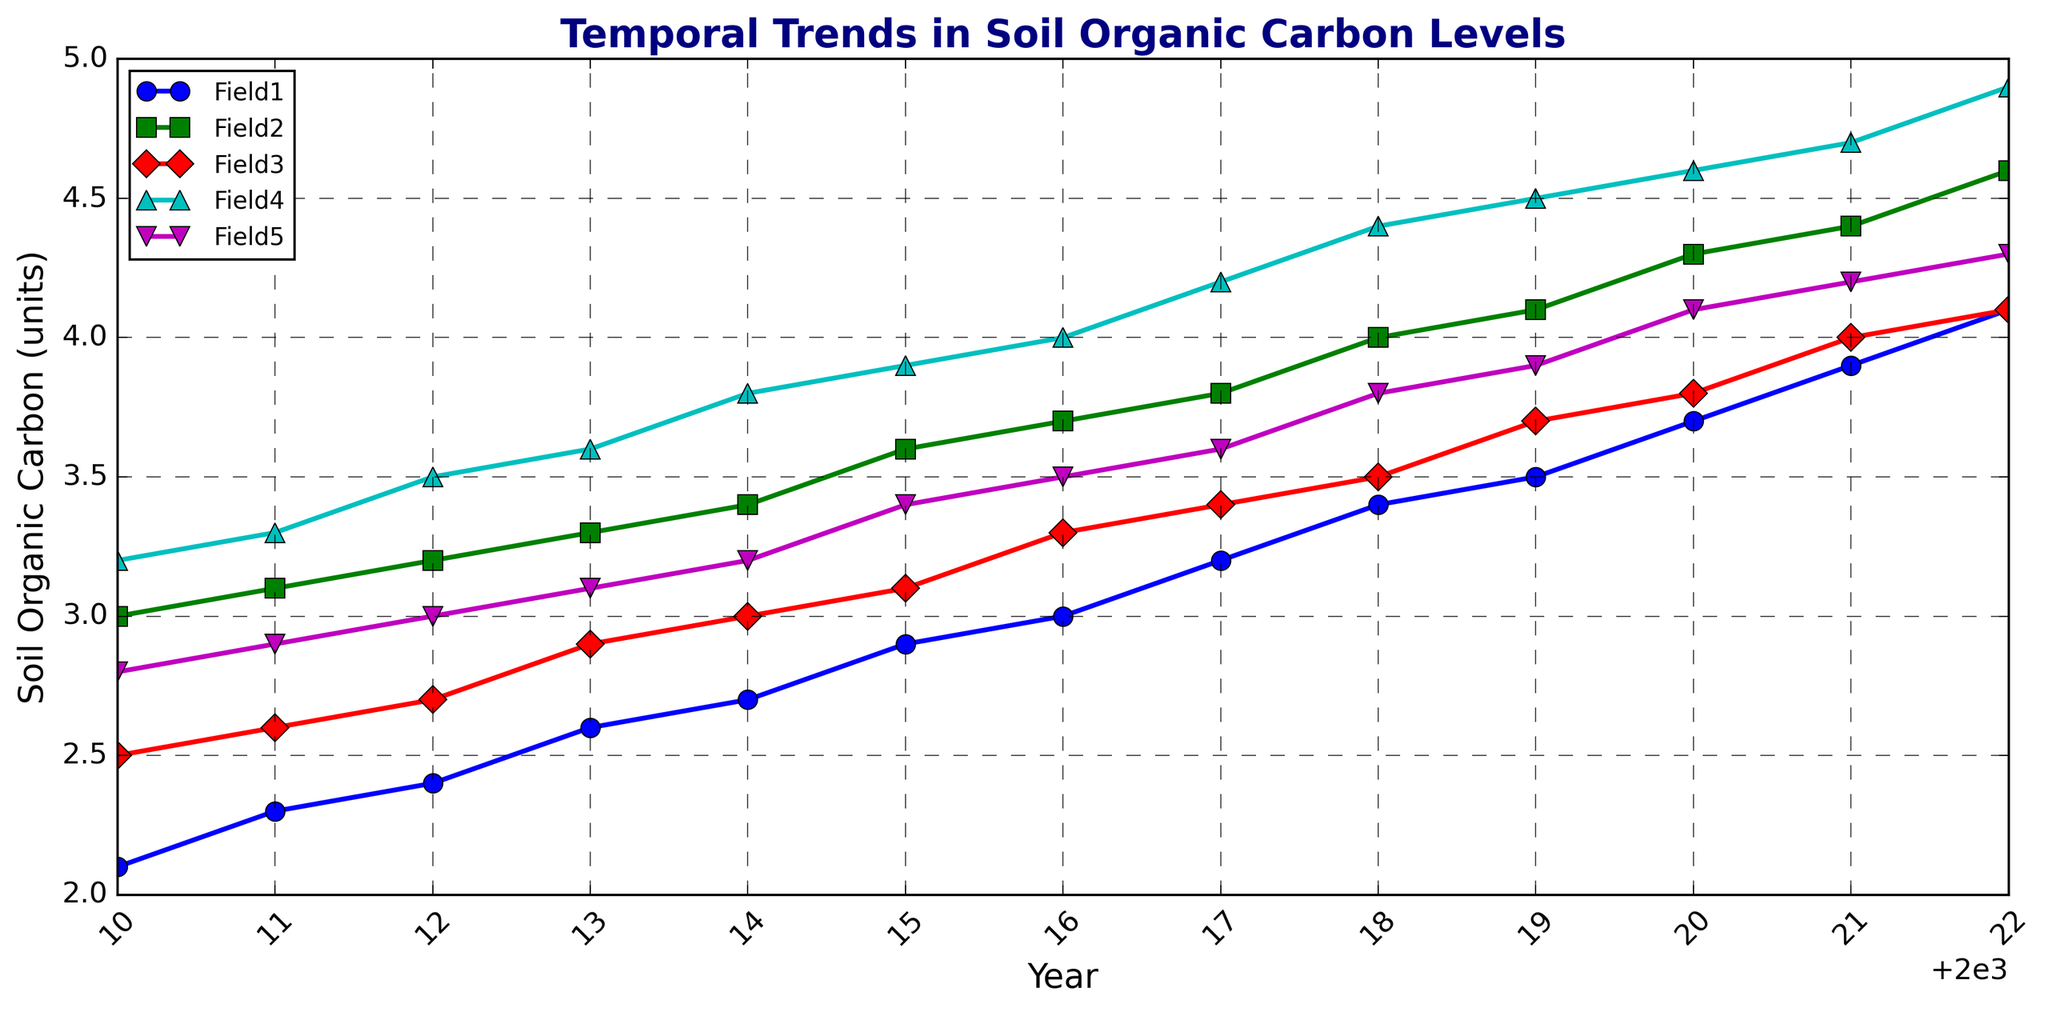What's the median value of Soil Organic Carbon for Field1 over the entire period? First, list the Soil Organic Carbon values for Field1: [2.1, 2.3, 2.4, 2.6, 2.7, 2.9, 3.0, 3.2, 3.4, 3.5, 3.7, 3.9, 4.1]. There are 13 values, so the median is the 7th value when ordered, which is 3.0.
Answer: 3.0 Which field had the highest Soil Organic Carbon level in 2022? Look at the plot for the data point corresponding to the year 2022. Among the fields, Field4 shows the highest Soil Organic Carbon level, which is 4.9.
Answer: Field4 Between Field3 and Field5, which field shows a greater increase in Soil Organic Carbon from 2010 to 2022? For Field3, the increase is 4.1 - 2.5 = 1.6. For Field5, the increase is 4.3 - 2.8 = 1.5. Comparatively, Field3 shows a slightly greater increase than Field5.
Answer: Field3 What's the average Soil Organic Carbon level for Field2 over the first five years? First, list the values for Field2 from 2010 to 2014: [3.0, 3.1, 3.2, 3.3, 3.4]. Sum these values: 3.0 + 3.1 + 3.2 + 3.3 + 3.4 = 16.0. The average is 16.0 / 5 = 3.2.
Answer: 3.2 Which year shows the highest Soil Organic Carbon level for Field1? Check each year's value for Field1: The highest value is 4.1, which occurs in 2022.
Answer: 2022 Is there any field that shows a linear increase in Soil Organic Carbon over the years? Check the trend lines visually for straightness. Field2 and Field3 both show linear and steady increases.
Answer: Field2, Field3 How much did the Soil Organic Carbon level in Field4 improve between 2015 and 2020? For 2015, the level is 3.9. For 2020, the level is 4.6. The improvement is 4.6 - 3.9 = 0.7.
Answer: 0.7 Which field has the least variation in Soil Organic Carbon levels over the period? Visually inspect the plot for the range of values. Field3 shows a relatively narrower range of points.
Answer: Field3 